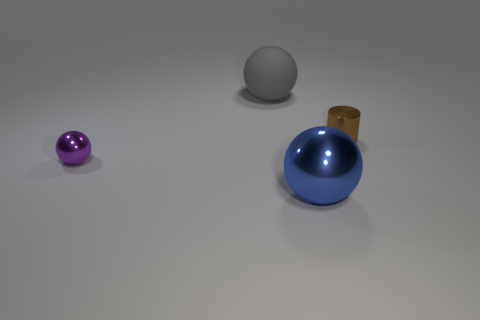There is a shiny cylinder; is it the same color as the large thing behind the small brown metallic object?
Ensure brevity in your answer.  No. Are there any small cylinders that are to the left of the large ball in front of the large sphere that is behind the blue shiny ball?
Keep it short and to the point. No. The small object that is made of the same material as the small purple ball is what shape?
Provide a short and direct response. Cylinder. Is there any other thing that has the same shape as the tiny brown thing?
Your answer should be compact. No. What shape is the brown metallic thing?
Offer a terse response. Cylinder. Do the shiny thing that is in front of the purple shiny object and the gray thing have the same shape?
Provide a short and direct response. Yes. Are there more big gray balls in front of the small metal cylinder than tiny brown cylinders to the left of the tiny sphere?
Offer a very short reply. No. How many other things are there of the same size as the brown cylinder?
Your answer should be very brief. 1. There is a small brown metallic object; does it have the same shape as the large object that is on the right side of the large matte ball?
Offer a terse response. No. How many shiny things are big things or tiny things?
Make the answer very short. 3. 